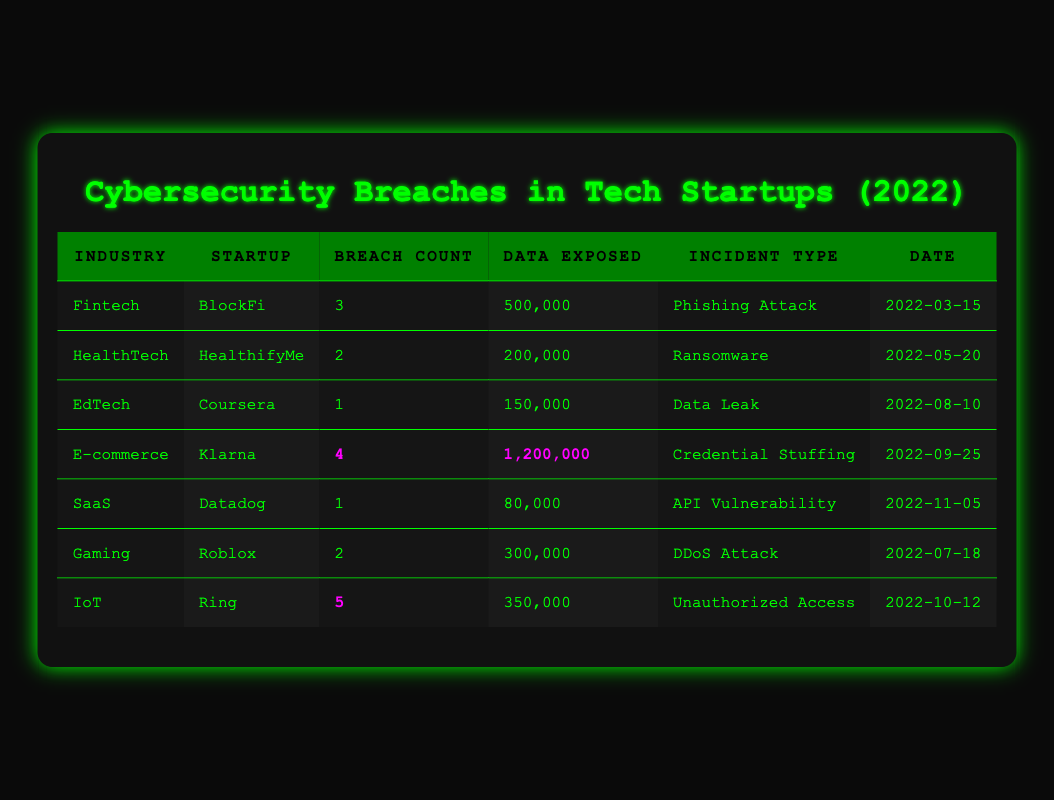What is the total number of breaches reported in the E-commerce industry? There is only one entry for the E-commerce industry in the table, which is Klarna, and it shows a breach count of 4.
Answer: 4 Which startup had the highest number of data exposed, and what was that amount? By examining the 'Data Exposed' column, Klarna stood out with 1,200,000 data exposed, which is greater than any other startup listed.
Answer: Klarna, 1,200,000 True or False: The Gaming industry had more breaches than the HealthTech industry. The Gaming industry had 2 breaches (Roblox) and the HealthTech industry had 2 breaches (HealthifyMe). Since they are equal, the statement is false.
Answer: False What is the average number of breaches across all industries listed in the table? We add the breach counts: 3 + 2 + 1 + 4 + 1 + 2 + 5 = 18. There are 7 entries, so the average is 18 divided by 7, which equals approximately 2.57.
Answer: 2.57 Which incident type resulted in the exposure of 500,000 records in the Fintech industry? The table indicates that the incident type for BlockFi in the Fintech sector that led to the exposure of 500,000 records was a Phishing Attack.
Answer: Phishing Attack Which startup reported the least number of breaches and what was the associated incident type? From the table, Coursera in the EdTech industry reported only 1 breach, and the incident type was a Data Leak.
Answer: Coursera, Data Leak How many total records were exposed across all entries in the table? We calculate the total by summing the data exposed for each startup: 500,000 + 200,000 + 150,000 + 1,200,000 + 80,000 + 300,000 + 350,000 = 2,780,000 records.
Answer: 2,780,000 True or False: The IoT industry had the same number of breaches as the Fintech industry. The IoT industry had 5 breaches (Ring) while the Fintech industry had 3 breaches (BlockFi). Since 5 does not equal 3, the statement is false.
Answer: False What was the incident type for the startup with the highest number of breaches? By looking at the IoT industry entry, Ring had the highest number of breaches with a count of 5, and the incident type was Unauthorized Access.
Answer: Unauthorized Access 